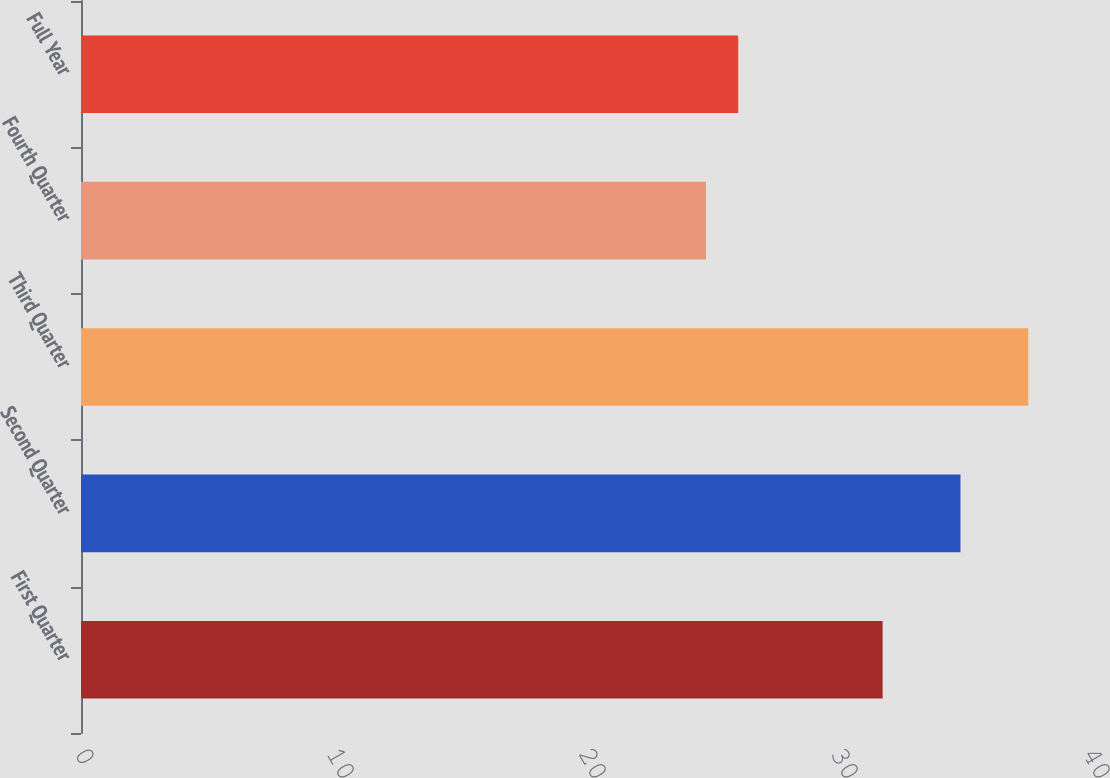<chart> <loc_0><loc_0><loc_500><loc_500><bar_chart><fcel>First Quarter<fcel>Second Quarter<fcel>Third Quarter<fcel>Fourth Quarter<fcel>Full Year<nl><fcel>31.81<fcel>34.9<fcel>37.59<fcel>24.8<fcel>26.08<nl></chart> 